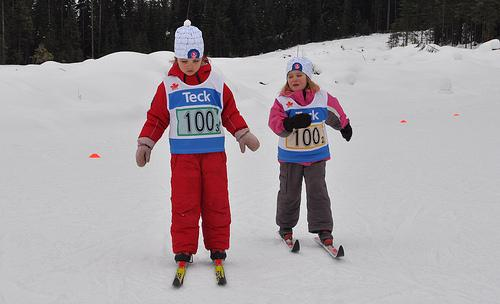Question: where was the picture taken?
Choices:
A. On a boat.
B. In a boat.
C. At the zoo.
D. On a ski slope.
Answer with the letter. Answer: D Question: what are the people doing?
Choices:
A. Playing.
B. Riding the lift.
C. Skiing.
D. Sliding.
Answer with the letter. Answer: C 